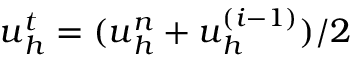Convert formula to latex. <formula><loc_0><loc_0><loc_500><loc_500>u _ { h } ^ { t } = ( u _ { h } ^ { n } + u _ { h } ^ { ( i - 1 ) } ) / 2</formula> 